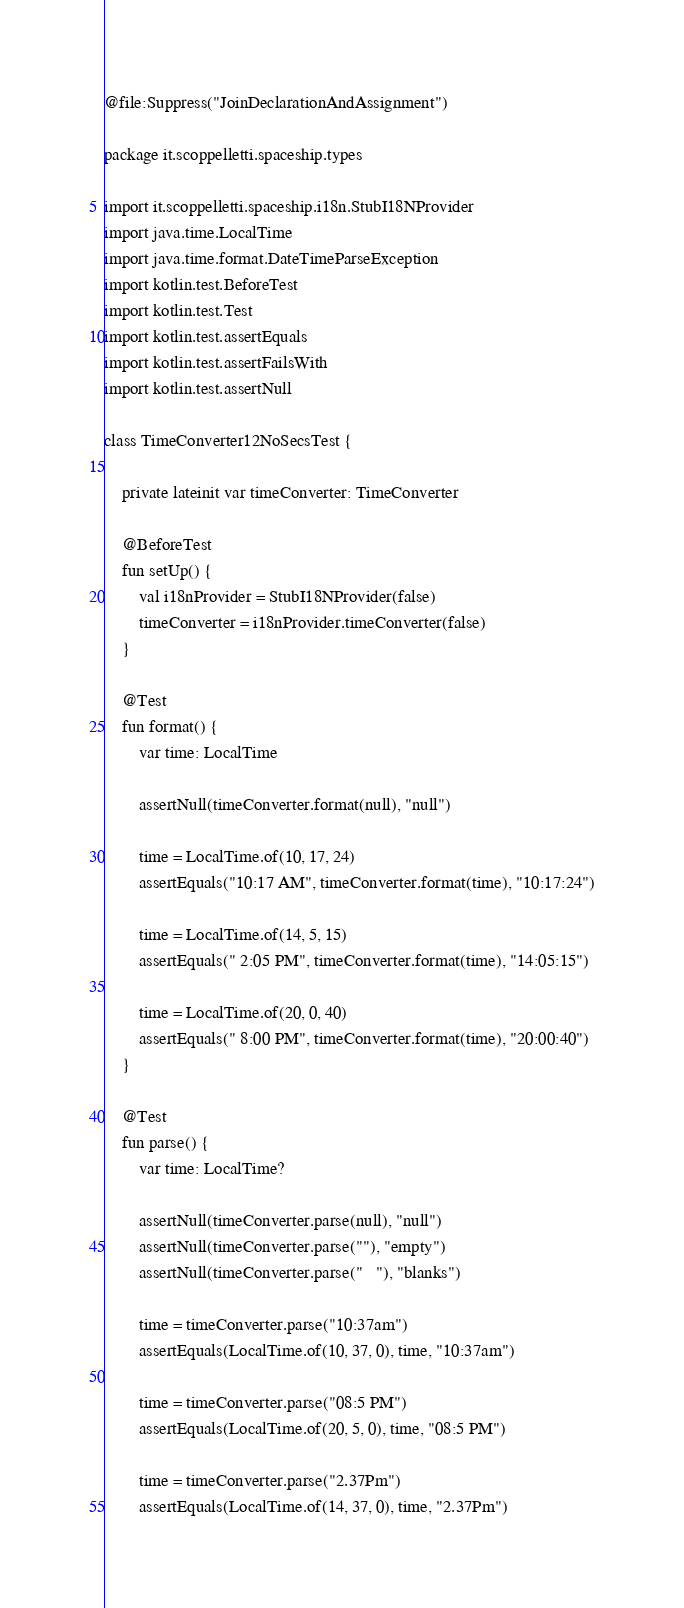<code> <loc_0><loc_0><loc_500><loc_500><_Kotlin_>@file:Suppress("JoinDeclarationAndAssignment")

package it.scoppelletti.spaceship.types

import it.scoppelletti.spaceship.i18n.StubI18NProvider
import java.time.LocalTime
import java.time.format.DateTimeParseException
import kotlin.test.BeforeTest
import kotlin.test.Test
import kotlin.test.assertEquals
import kotlin.test.assertFailsWith
import kotlin.test.assertNull

class TimeConverter12NoSecsTest {

    private lateinit var timeConverter: TimeConverter

    @BeforeTest
    fun setUp() {
        val i18nProvider = StubI18NProvider(false)
        timeConverter = i18nProvider.timeConverter(false)
    }

    @Test
    fun format() {
        var time: LocalTime

        assertNull(timeConverter.format(null), "null")

        time = LocalTime.of(10, 17, 24)
        assertEquals("10:17 AM", timeConverter.format(time), "10:17:24")

        time = LocalTime.of(14, 5, 15)
        assertEquals(" 2:05 PM", timeConverter.format(time), "14:05:15")

        time = LocalTime.of(20, 0, 40)
        assertEquals(" 8:00 PM", timeConverter.format(time), "20:00:40")
    }

    @Test
    fun parse() {
        var time: LocalTime?

        assertNull(timeConverter.parse(null), "null")
        assertNull(timeConverter.parse(""), "empty")
        assertNull(timeConverter.parse("   "), "blanks")

        time = timeConverter.parse("10:37am")
        assertEquals(LocalTime.of(10, 37, 0), time, "10:37am")

        time = timeConverter.parse("08:5 PM")
        assertEquals(LocalTime.of(20, 5, 0), time, "08:5 PM")

        time = timeConverter.parse("2.37Pm")
        assertEquals(LocalTime.of(14, 37, 0), time, "2.37Pm")
</code> 